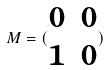Convert formula to latex. <formula><loc_0><loc_0><loc_500><loc_500>M = ( \begin{matrix} 0 & 0 \\ 1 & 0 \end{matrix} )</formula> 